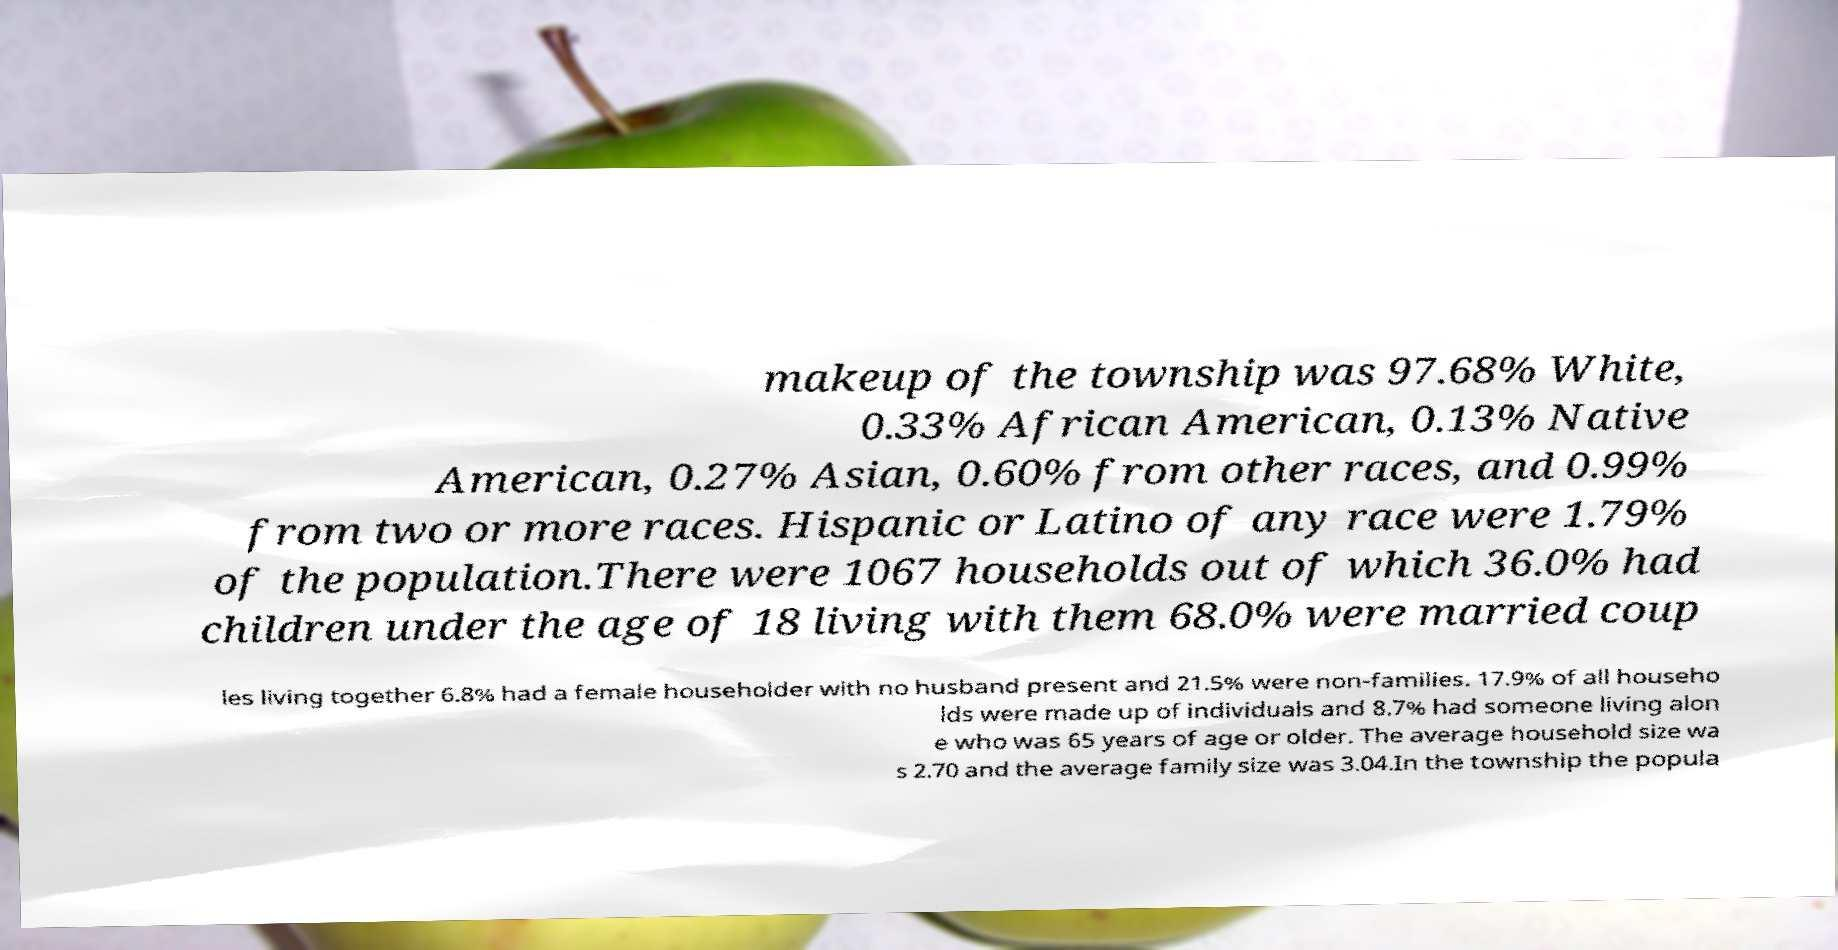Could you extract and type out the text from this image? makeup of the township was 97.68% White, 0.33% African American, 0.13% Native American, 0.27% Asian, 0.60% from other races, and 0.99% from two or more races. Hispanic or Latino of any race were 1.79% of the population.There were 1067 households out of which 36.0% had children under the age of 18 living with them 68.0% were married coup les living together 6.8% had a female householder with no husband present and 21.5% were non-families. 17.9% of all househo lds were made up of individuals and 8.7% had someone living alon e who was 65 years of age or older. The average household size wa s 2.70 and the average family size was 3.04.In the township the popula 